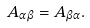Convert formula to latex. <formula><loc_0><loc_0><loc_500><loc_500>A _ { \alpha \beta } = A _ { \beta \alpha } .</formula> 